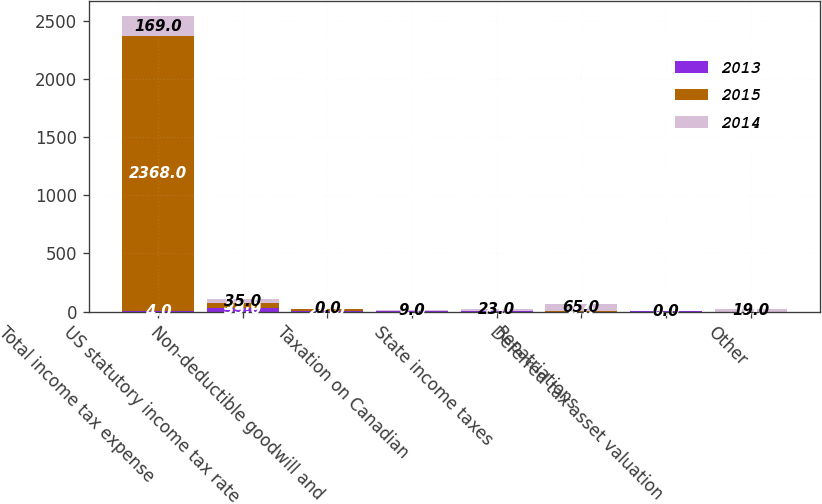Convert chart to OTSL. <chart><loc_0><loc_0><loc_500><loc_500><stacked_bar_chart><ecel><fcel>Total income tax expense<fcel>US statutory income tax rate<fcel>Non-deductible goodwill and<fcel>Taxation on Canadian<fcel>State income taxes<fcel>Repatriations<fcel>Deferred tax asset valuation<fcel>Other<nl><fcel>2013<fcel>4<fcel>35<fcel>2<fcel>1<fcel>1<fcel>0<fcel>4<fcel>0<nl><fcel>2015<fcel>2368<fcel>35<fcel>23<fcel>4<fcel>2<fcel>2<fcel>0<fcel>0<nl><fcel>2014<fcel>169<fcel>35<fcel>0<fcel>9<fcel>23<fcel>65<fcel>0<fcel>19<nl></chart> 